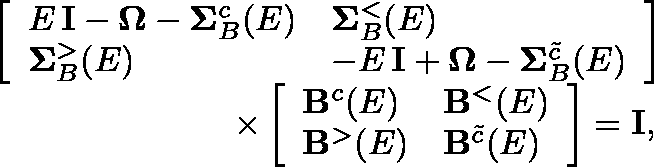Convert formula to latex. <formula><loc_0><loc_0><loc_500><loc_500>\begin{array} { r l } & { \left [ \begin{array} { l l } { E \, I - \Omega - \Sigma _ { B } ^ { c } ( E ) } & { \Sigma _ { B } ^ { < } ( E ) } \\ { \Sigma _ { B } ^ { > } ( E ) } & { - E \, I + \Omega - \Sigma _ { B } ^ { \tilde { c } } ( E ) } \end{array} \right ] } \\ & { \quad \times \left [ \begin{array} { l l } { B ^ { c } ( E ) } & { B ^ { < } ( E ) } \\ { B ^ { > } ( E ) } & { B ^ { \tilde { c } } ( E ) } \end{array} \right ] = I , } \end{array}</formula> 